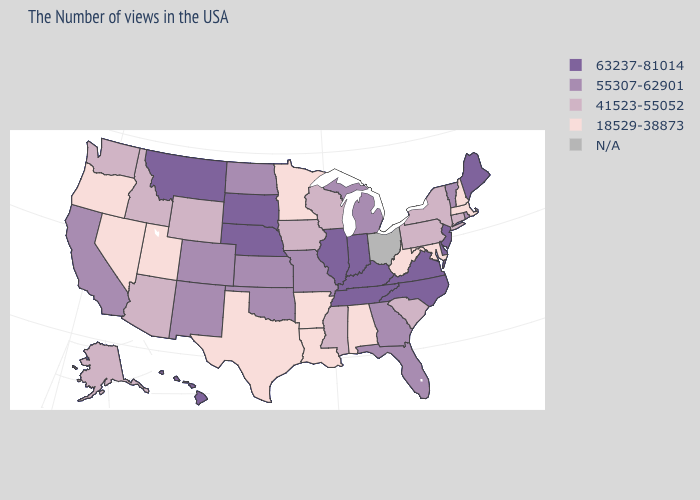Does Kansas have the highest value in the USA?
Answer briefly. No. Name the states that have a value in the range 41523-55052?
Give a very brief answer. Connecticut, New York, Pennsylvania, South Carolina, Wisconsin, Mississippi, Iowa, Wyoming, Arizona, Idaho, Washington, Alaska. What is the value of Nebraska?
Be succinct. 63237-81014. Is the legend a continuous bar?
Give a very brief answer. No. What is the lowest value in the USA?
Concise answer only. 18529-38873. What is the value of Montana?
Answer briefly. 63237-81014. Name the states that have a value in the range 18529-38873?
Answer briefly. Massachusetts, New Hampshire, Maryland, West Virginia, Alabama, Louisiana, Arkansas, Minnesota, Texas, Utah, Nevada, Oregon. What is the highest value in states that border Rhode Island?
Be succinct. 41523-55052. Does Montana have the lowest value in the West?
Concise answer only. No. Is the legend a continuous bar?
Quick response, please. No. What is the value of New Jersey?
Concise answer only. 63237-81014. What is the value of Michigan?
Keep it brief. 55307-62901. What is the value of Colorado?
Be succinct. 55307-62901. Name the states that have a value in the range 18529-38873?
Keep it brief. Massachusetts, New Hampshire, Maryland, West Virginia, Alabama, Louisiana, Arkansas, Minnesota, Texas, Utah, Nevada, Oregon. 